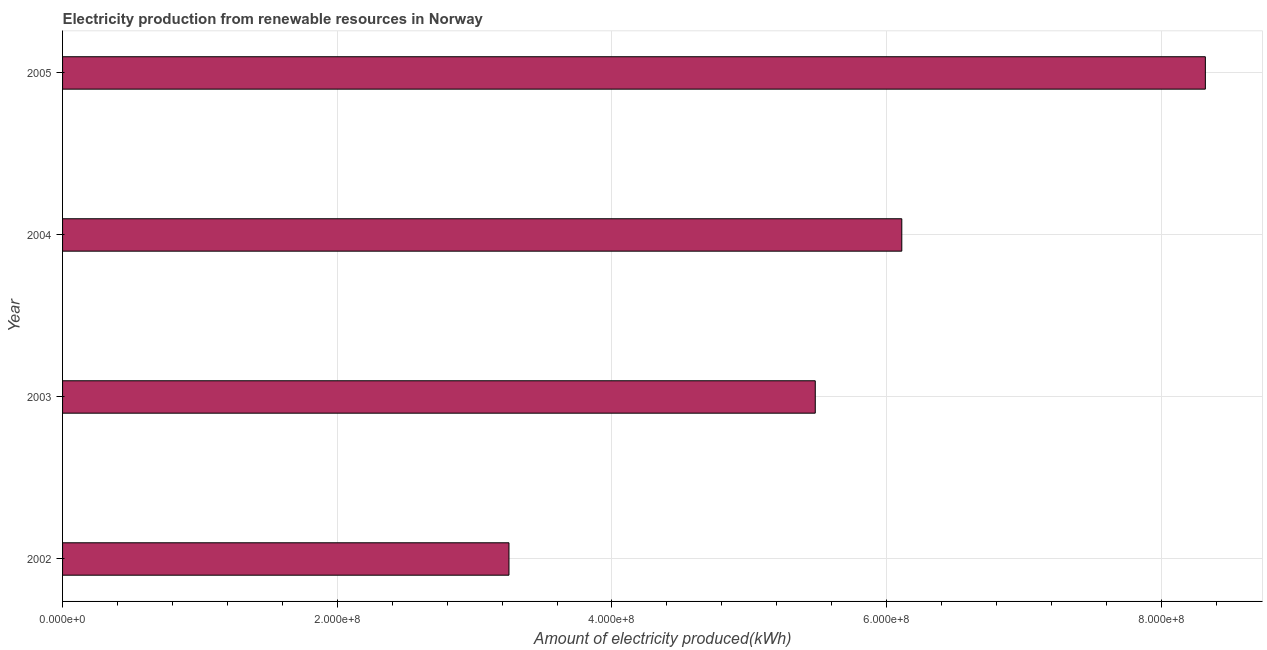Does the graph contain any zero values?
Your response must be concise. No. Does the graph contain grids?
Ensure brevity in your answer.  Yes. What is the title of the graph?
Make the answer very short. Electricity production from renewable resources in Norway. What is the label or title of the X-axis?
Keep it short and to the point. Amount of electricity produced(kWh). What is the amount of electricity produced in 2003?
Your answer should be compact. 5.48e+08. Across all years, what is the maximum amount of electricity produced?
Provide a succinct answer. 8.32e+08. Across all years, what is the minimum amount of electricity produced?
Provide a succinct answer. 3.25e+08. In which year was the amount of electricity produced maximum?
Your answer should be very brief. 2005. In which year was the amount of electricity produced minimum?
Provide a succinct answer. 2002. What is the sum of the amount of electricity produced?
Keep it short and to the point. 2.32e+09. What is the difference between the amount of electricity produced in 2002 and 2003?
Provide a succinct answer. -2.23e+08. What is the average amount of electricity produced per year?
Offer a terse response. 5.79e+08. What is the median amount of electricity produced?
Make the answer very short. 5.80e+08. What is the ratio of the amount of electricity produced in 2003 to that in 2005?
Keep it short and to the point. 0.66. Is the difference between the amount of electricity produced in 2002 and 2003 greater than the difference between any two years?
Your answer should be compact. No. What is the difference between the highest and the second highest amount of electricity produced?
Offer a very short reply. 2.21e+08. Is the sum of the amount of electricity produced in 2004 and 2005 greater than the maximum amount of electricity produced across all years?
Give a very brief answer. Yes. What is the difference between the highest and the lowest amount of electricity produced?
Your response must be concise. 5.07e+08. In how many years, is the amount of electricity produced greater than the average amount of electricity produced taken over all years?
Ensure brevity in your answer.  2. How many years are there in the graph?
Your answer should be very brief. 4. What is the difference between two consecutive major ticks on the X-axis?
Offer a very short reply. 2.00e+08. What is the Amount of electricity produced(kWh) in 2002?
Provide a succinct answer. 3.25e+08. What is the Amount of electricity produced(kWh) in 2003?
Your response must be concise. 5.48e+08. What is the Amount of electricity produced(kWh) in 2004?
Provide a short and direct response. 6.11e+08. What is the Amount of electricity produced(kWh) of 2005?
Keep it short and to the point. 8.32e+08. What is the difference between the Amount of electricity produced(kWh) in 2002 and 2003?
Give a very brief answer. -2.23e+08. What is the difference between the Amount of electricity produced(kWh) in 2002 and 2004?
Offer a terse response. -2.86e+08. What is the difference between the Amount of electricity produced(kWh) in 2002 and 2005?
Keep it short and to the point. -5.07e+08. What is the difference between the Amount of electricity produced(kWh) in 2003 and 2004?
Your answer should be compact. -6.30e+07. What is the difference between the Amount of electricity produced(kWh) in 2003 and 2005?
Provide a succinct answer. -2.84e+08. What is the difference between the Amount of electricity produced(kWh) in 2004 and 2005?
Your answer should be compact. -2.21e+08. What is the ratio of the Amount of electricity produced(kWh) in 2002 to that in 2003?
Your response must be concise. 0.59. What is the ratio of the Amount of electricity produced(kWh) in 2002 to that in 2004?
Ensure brevity in your answer.  0.53. What is the ratio of the Amount of electricity produced(kWh) in 2002 to that in 2005?
Ensure brevity in your answer.  0.39. What is the ratio of the Amount of electricity produced(kWh) in 2003 to that in 2004?
Your answer should be very brief. 0.9. What is the ratio of the Amount of electricity produced(kWh) in 2003 to that in 2005?
Provide a succinct answer. 0.66. What is the ratio of the Amount of electricity produced(kWh) in 2004 to that in 2005?
Offer a very short reply. 0.73. 